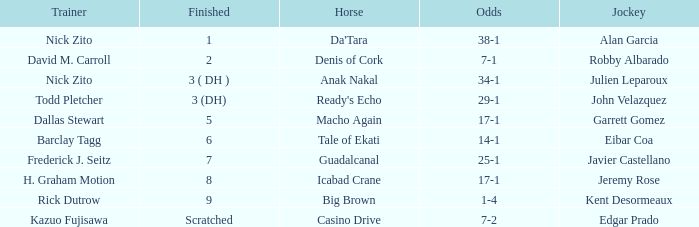What are the Odds for the Horse called Ready's Echo? 29-1. 